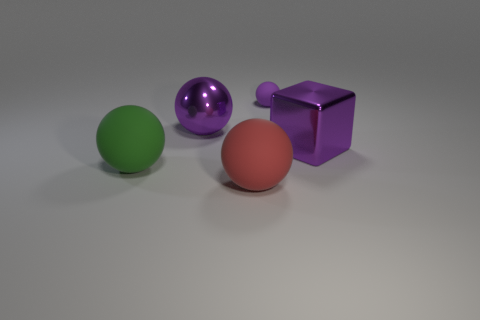Are there any other things that have the same size as the purple rubber ball?
Your answer should be very brief. No. The small rubber object that is the same color as the big metallic sphere is what shape?
Offer a terse response. Sphere. Are there an equal number of purple metal things right of the shiny sphere and tiny purple objects?
Ensure brevity in your answer.  Yes. What is the material of the large purple object that is on the right side of the purple thing to the left of the rubber object that is behind the large purple block?
Provide a succinct answer. Metal. There is a red thing that is made of the same material as the green ball; what shape is it?
Offer a very short reply. Sphere. Are there any other things that are the same color as the metal block?
Give a very brief answer. Yes. What number of big purple things are to the left of the big purple thing that is on the right side of the big matte sphere to the right of the big metal sphere?
Give a very brief answer. 1. What number of green objects are metallic spheres or big rubber objects?
Offer a terse response. 1. Is the size of the block the same as the rubber thing that is behind the purple metallic cube?
Provide a succinct answer. No. There is a tiny object that is the same shape as the large red matte object; what material is it?
Provide a short and direct response. Rubber. 